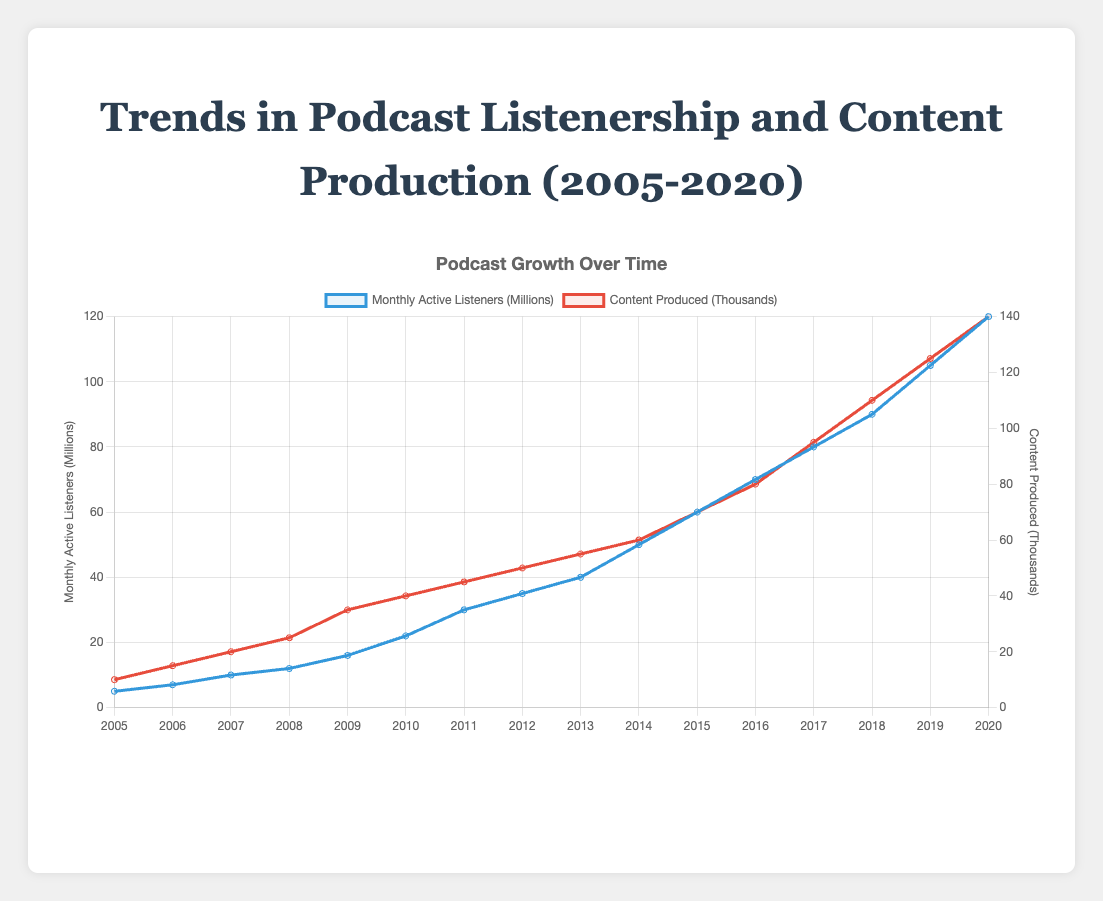What was the trend in monthly active listeners from 2005 to 2020? The monthly active listeners generally increased from 5 million in 2005 to 120 million in 2020, showing a consistent upward trend throughout the years.
Answer: Increased How does the trend in content production compare to the trend in monthly active listeners? Both content production and monthly active listeners showed a consistent upward trend from 2005 to 2020. Content production increased from 10 thousand in 2005 to 140 thousand in 2020, generally paralleling the increase in listenership.
Answer: Paralleled Which year experienced the highest increase in monthly active listeners? To determine this, examine the differences in monthly active listeners between consecutive years and identify the largest one. The most considerable increase occurred between 2014 and 2015, where the number went from 50 million to 60 million, reflecting an increase of 10 million.
Answer: 2014 to 2015 In which years did "The Joe Rogan Experience" top the podcast chart, and what were the monthly active listener counts for those years? "The Joe Rogan Experience" topped the podcast chart in 2011, 2012, 2019, and 2020. The listener counts were 30 million (2011), 35 million (2012), 105 million (2019), and 120 million (2020).
Answer: 2011, 2012, 2019, 2020: 30M, 35M, 105M, 120M What is the average number of content produced from 2005 to 2020? Calculate the sum of content produced from 2005 to 2020 and divide by the number of years. The sum is 895 thousand, and the average is 895/16 = 56 thousand.
Answer: 56 thousand From 2009 to 2010, how much did the content production grow in percentage? Content production grew from 35 thousand in 2009 to 40 thousand in 2010. The percentage increase is calculated as ((40 - 35) / 35) * 100 = 14.29%.
Answer: 14.29% How did the list of top podcasts evolve every 2 years from 2005 onwards? Starting from 2005, the top podcasts every 2 years were: 2005 - The Ricky Gervais Show, 2007 - This American Life, 2009 - Stuff You Should Know, 2011 - The Joe Rogan Experience, 2013 - Serial, 2015 - Criminal, 2017 - The Daily, 2019 - The Joe Rogan Experience.
Answer: The Ricky Gervais Show, This American Life, Stuff You Should Know, The Joe Rogan Experience, Serial, Criminal, The Daily, The Joe Rogan Experience By visual inspection, how do the colors of the lines representing monthly active listeners and content production help differentiate the two data sets? The line for monthly active listeners is represented with a blue color, while the content production line is colored red, making it visually easy to distinguish between the two data sets.
Answer: Blue and Red 